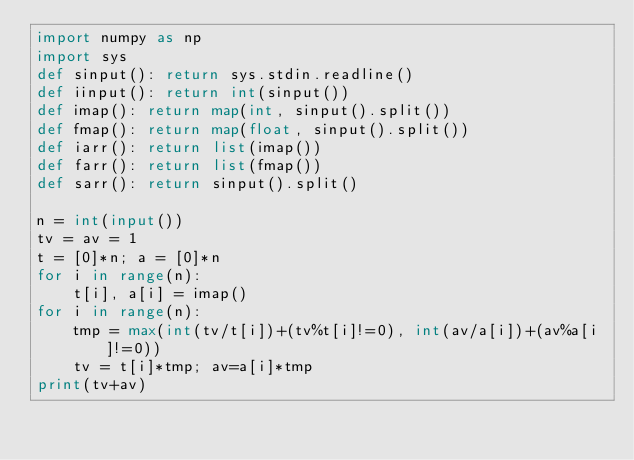<code> <loc_0><loc_0><loc_500><loc_500><_Python_>import numpy as np
import sys
def sinput(): return sys.stdin.readline()
def iinput(): return int(sinput())
def imap(): return map(int, sinput().split())
def fmap(): return map(float, sinput().split())
def iarr(): return list(imap())
def farr(): return list(fmap())
def sarr(): return sinput().split()

n = int(input())
tv = av = 1
t = [0]*n; a = [0]*n
for i in range(n):
    t[i], a[i] = imap()
for i in range(n):
    tmp = max(int(tv/t[i])+(tv%t[i]!=0), int(av/a[i])+(av%a[i]!=0))
    tv = t[i]*tmp; av=a[i]*tmp
print(tv+av)</code> 